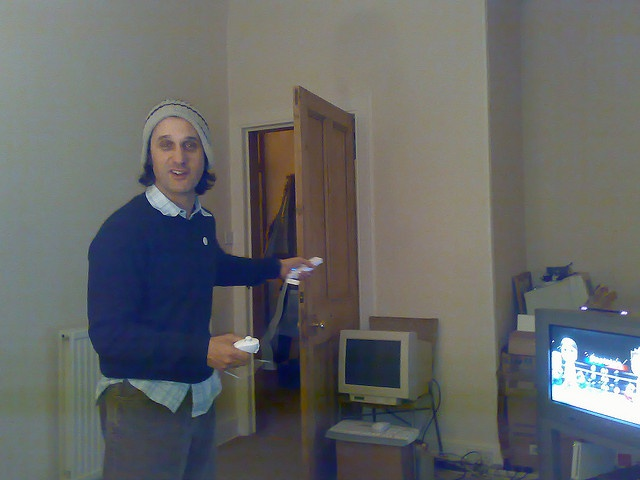Describe the objects in this image and their specific colors. I can see people in darkgray, navy, gray, and darkblue tones, tv in darkgray, white, and blue tones, tv in darkgray, black, gray, navy, and darkgreen tones, keyboard in darkgray, gray, blue, navy, and darkgreen tones, and remote in darkgray and gray tones in this image. 